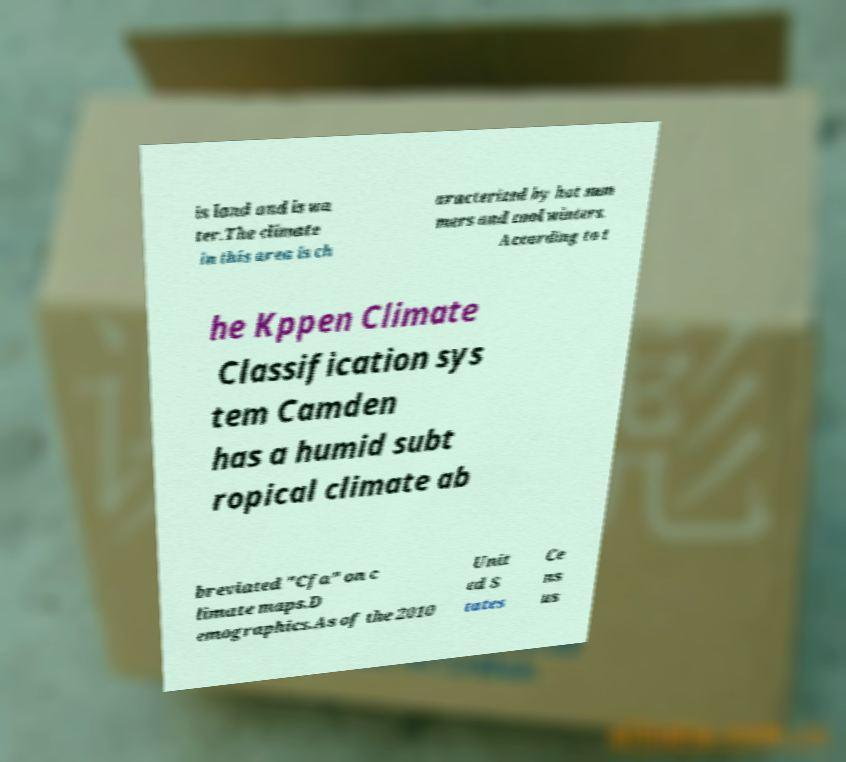Can you accurately transcribe the text from the provided image for me? is land and is wa ter.The climate in this area is ch aracterized by hot sum mers and cool winters. According to t he Kppen Climate Classification sys tem Camden has a humid subt ropical climate ab breviated "Cfa" on c limate maps.D emographics.As of the 2010 Unit ed S tates Ce ns us 